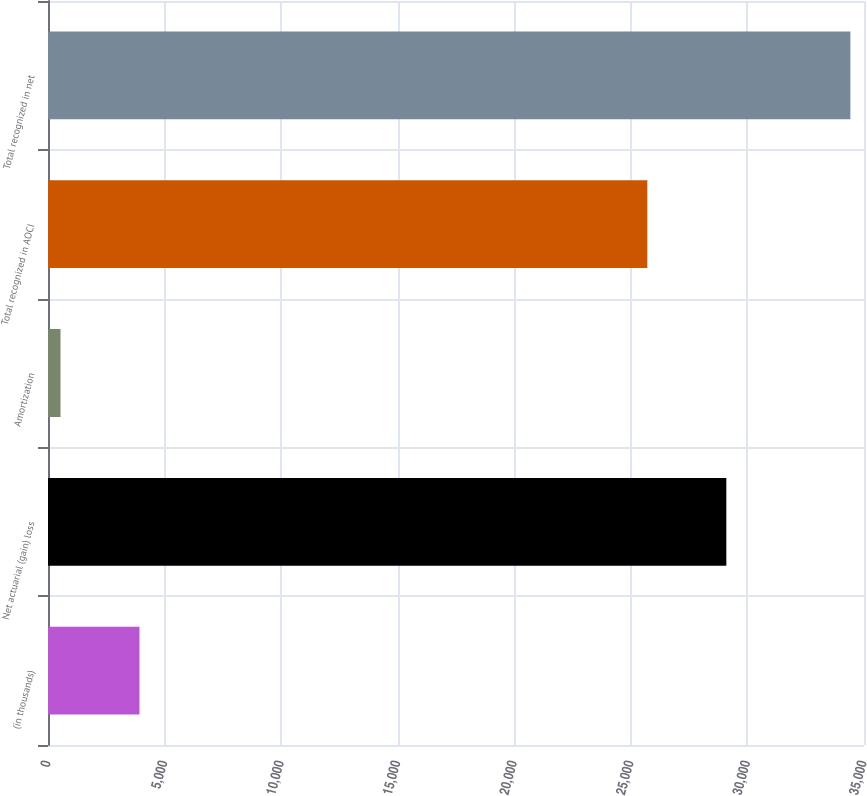<chart> <loc_0><loc_0><loc_500><loc_500><bar_chart><fcel>(in thousands)<fcel>Net actuarial (gain) loss<fcel>Amortization<fcel>Total recognized in AOCI<fcel>Total recognized in net<nl><fcel>3924<fcel>29095<fcel>536<fcel>25707<fcel>34416<nl></chart> 